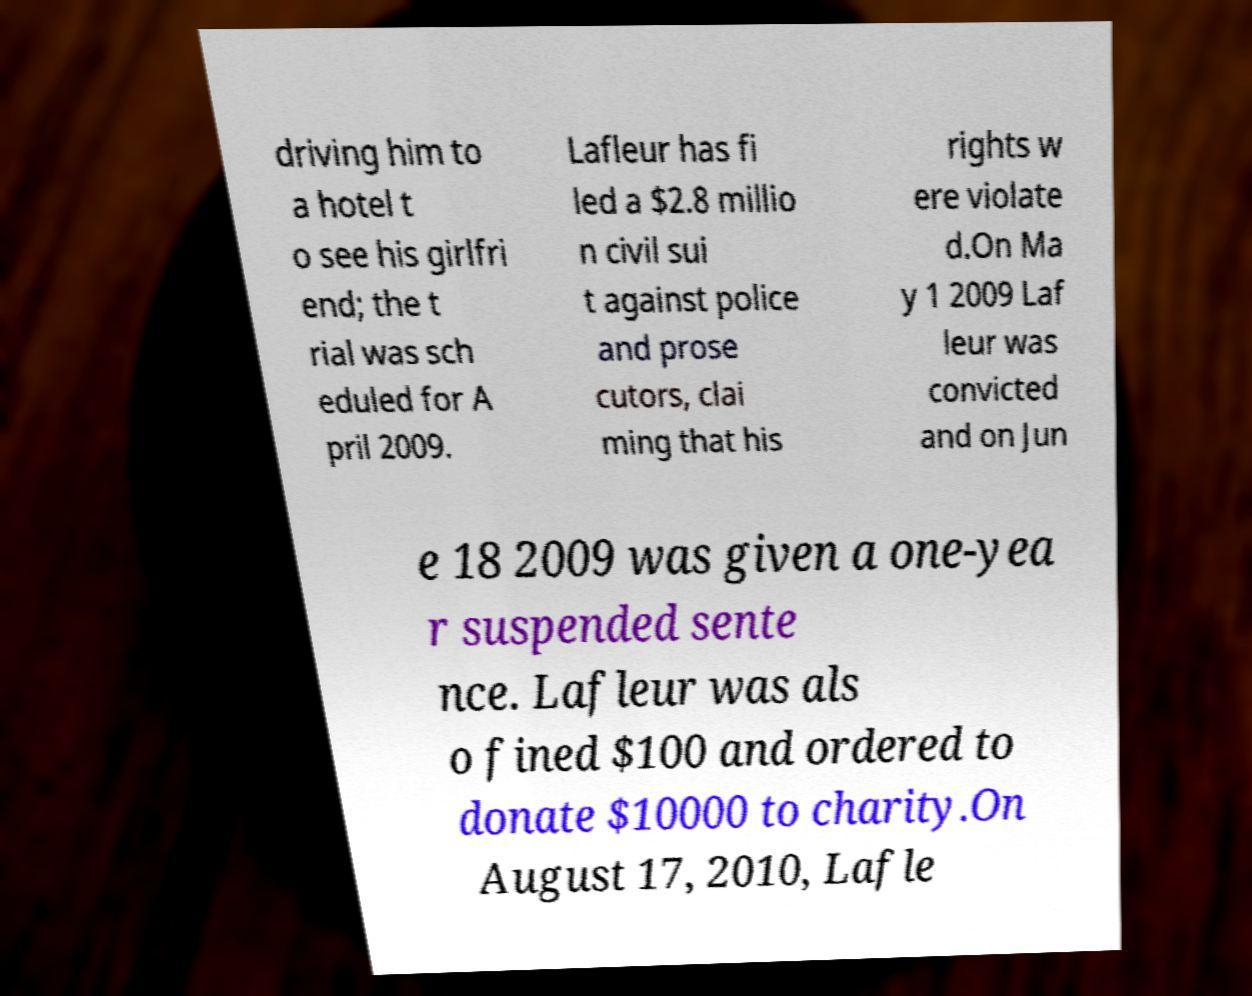Please read and relay the text visible in this image. What does it say? driving him to a hotel t o see his girlfri end; the t rial was sch eduled for A pril 2009. Lafleur has fi led a $2.8 millio n civil sui t against police and prose cutors, clai ming that his rights w ere violate d.On Ma y 1 2009 Laf leur was convicted and on Jun e 18 2009 was given a one-yea r suspended sente nce. Lafleur was als o fined $100 and ordered to donate $10000 to charity.On August 17, 2010, Lafle 